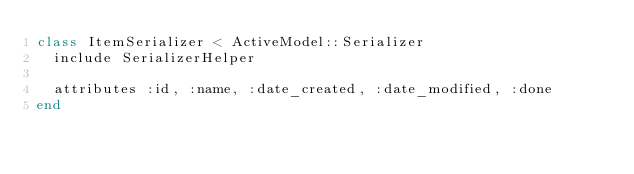Convert code to text. <code><loc_0><loc_0><loc_500><loc_500><_Ruby_>class ItemSerializer < ActiveModel::Serializer
  include SerializerHelper

  attributes :id, :name, :date_created, :date_modified, :done
end
</code> 